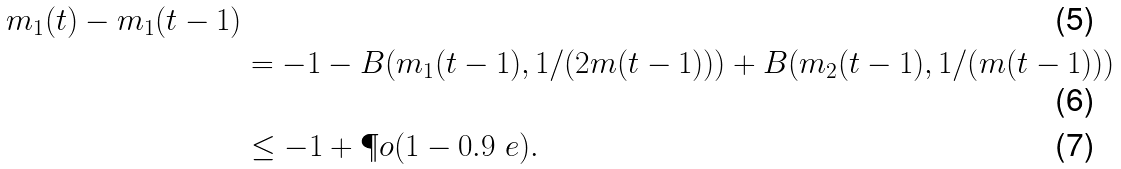Convert formula to latex. <formula><loc_0><loc_0><loc_500><loc_500>{ m _ { 1 } ( t ) - m _ { 1 } ( t - 1 ) } \\ & = - 1 - B ( m _ { 1 } ( t - 1 ) , 1 / ( 2 m ( t - 1 ) ) ) + B ( m _ { 2 } ( t - 1 ) , 1 / ( m ( t - 1 ) ) ) \\ & \leq - 1 + \P o ( 1 - 0 . 9 \ e ) .</formula> 